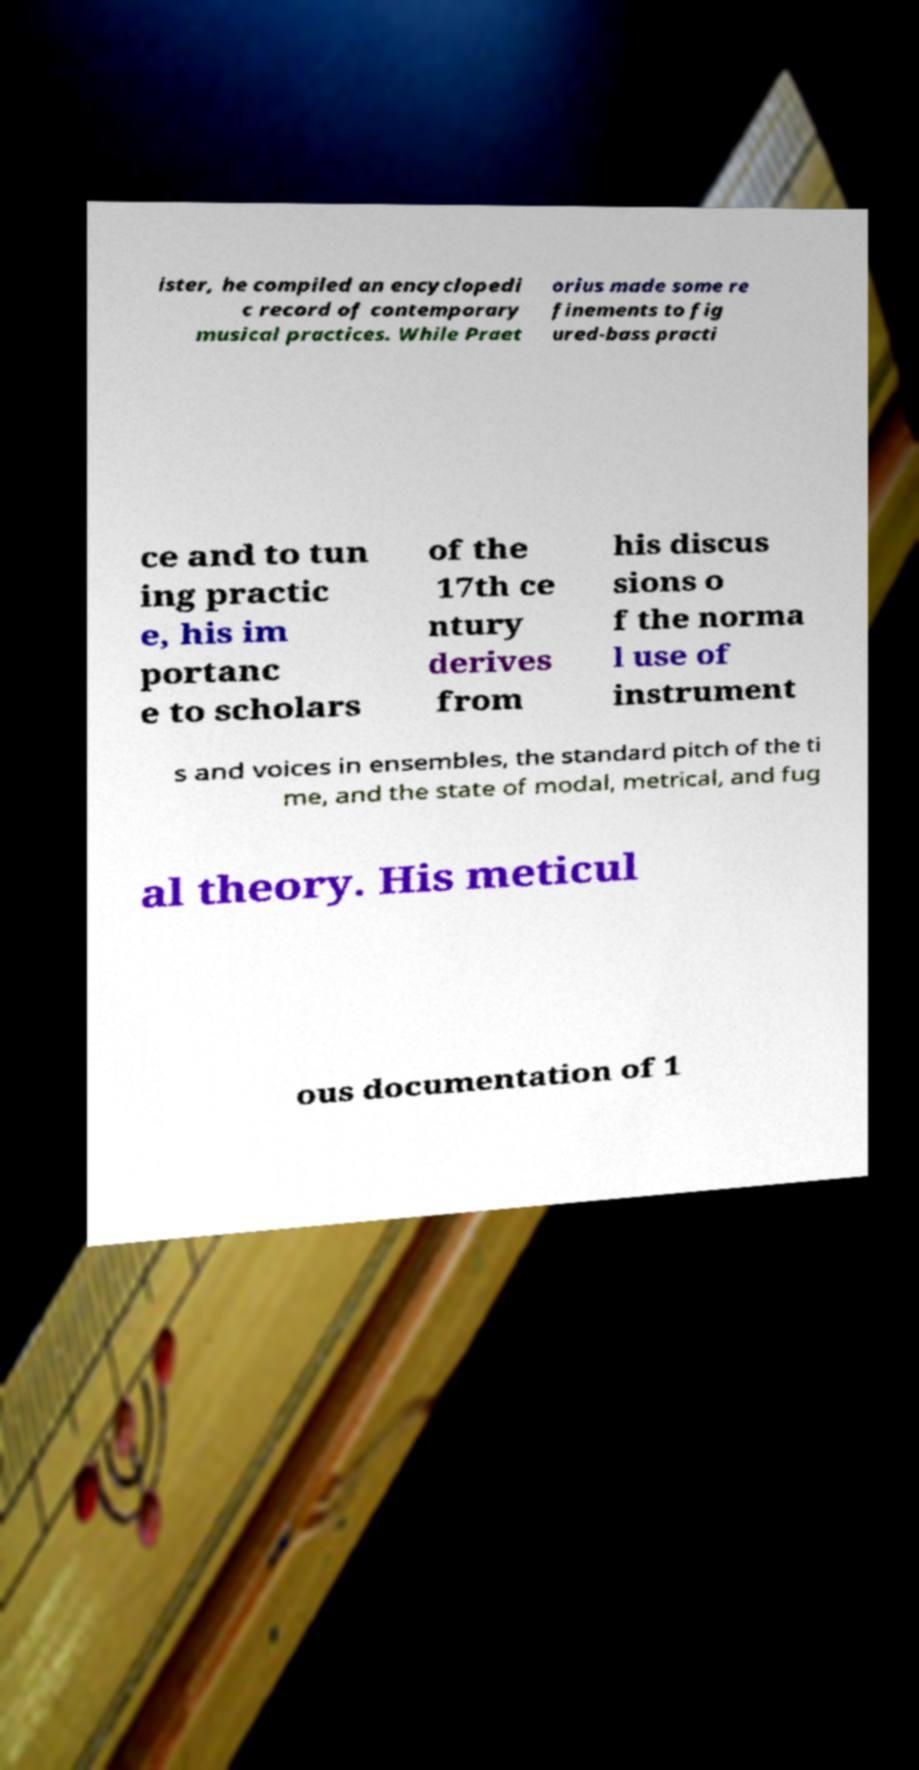Can you read and provide the text displayed in the image?This photo seems to have some interesting text. Can you extract and type it out for me? ister, he compiled an encyclopedi c record of contemporary musical practices. While Praet orius made some re finements to fig ured-bass practi ce and to tun ing practic e, his im portanc e to scholars of the 17th ce ntury derives from his discus sions o f the norma l use of instrument s and voices in ensembles, the standard pitch of the ti me, and the state of modal, metrical, and fug al theory. His meticul ous documentation of 1 